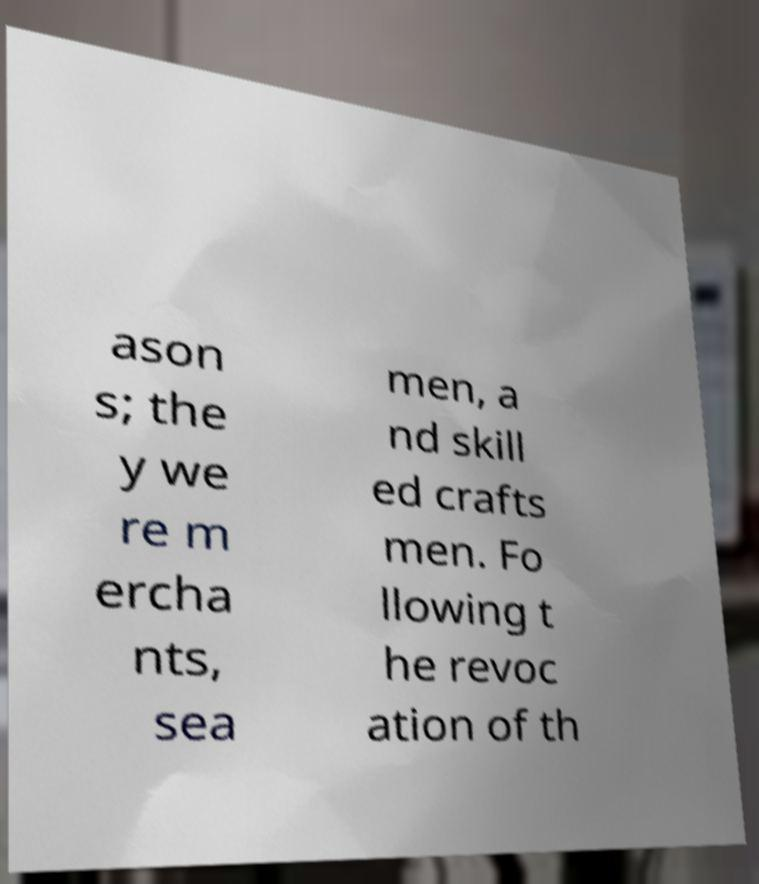Can you accurately transcribe the text from the provided image for me? ason s; the y we re m ercha nts, sea men, a nd skill ed crafts men. Fo llowing t he revoc ation of th 